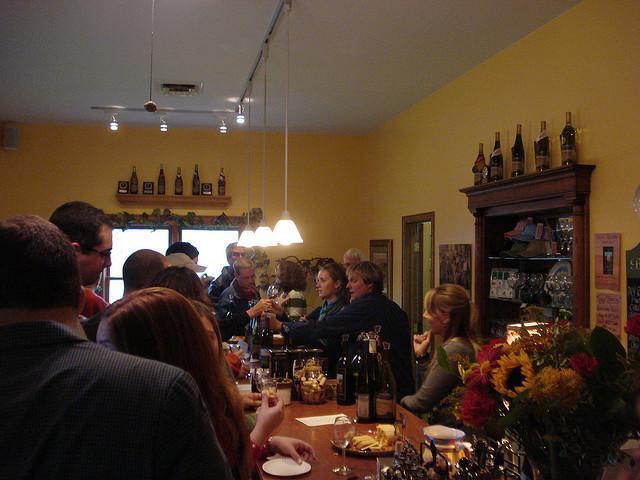How many lights are hanging from the ceiling?
Give a very brief answer. 7. How many people are in the photo?
Give a very brief answer. 7. 